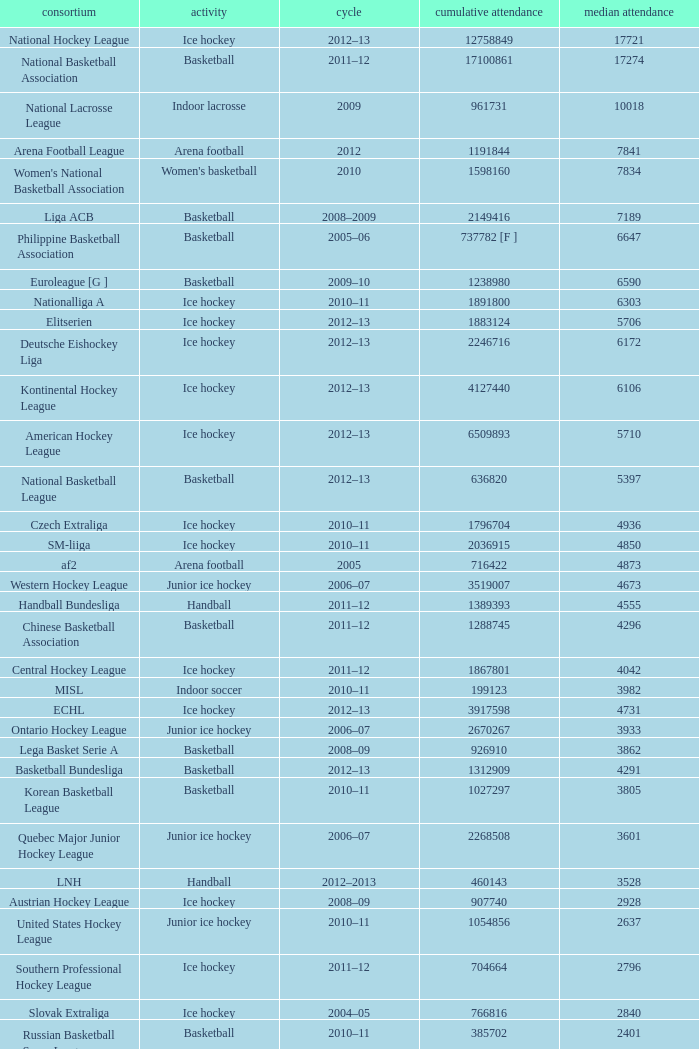What's the average attendance of the league with a total attendance of 2268508? 3601.0. 